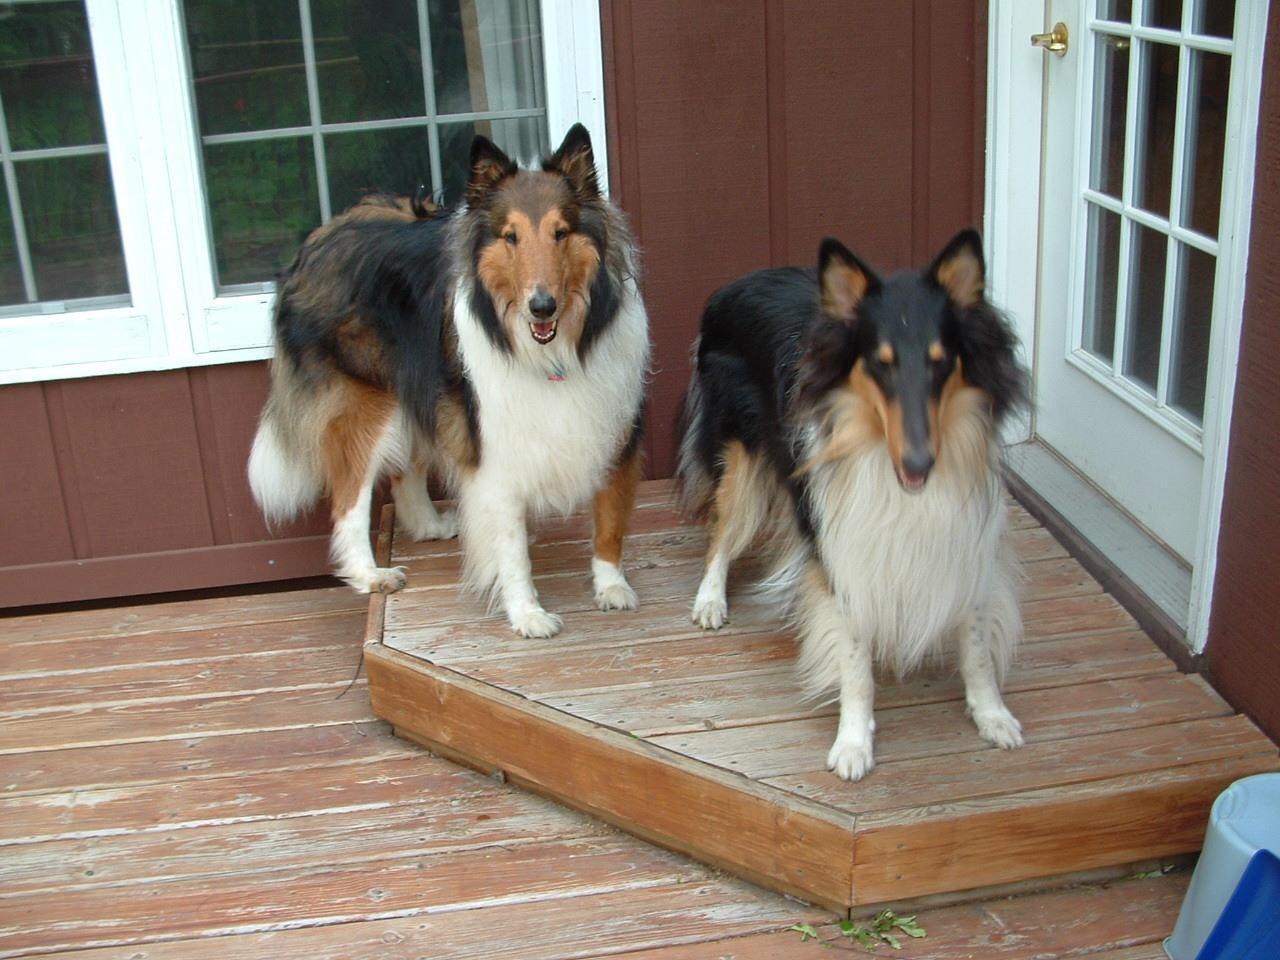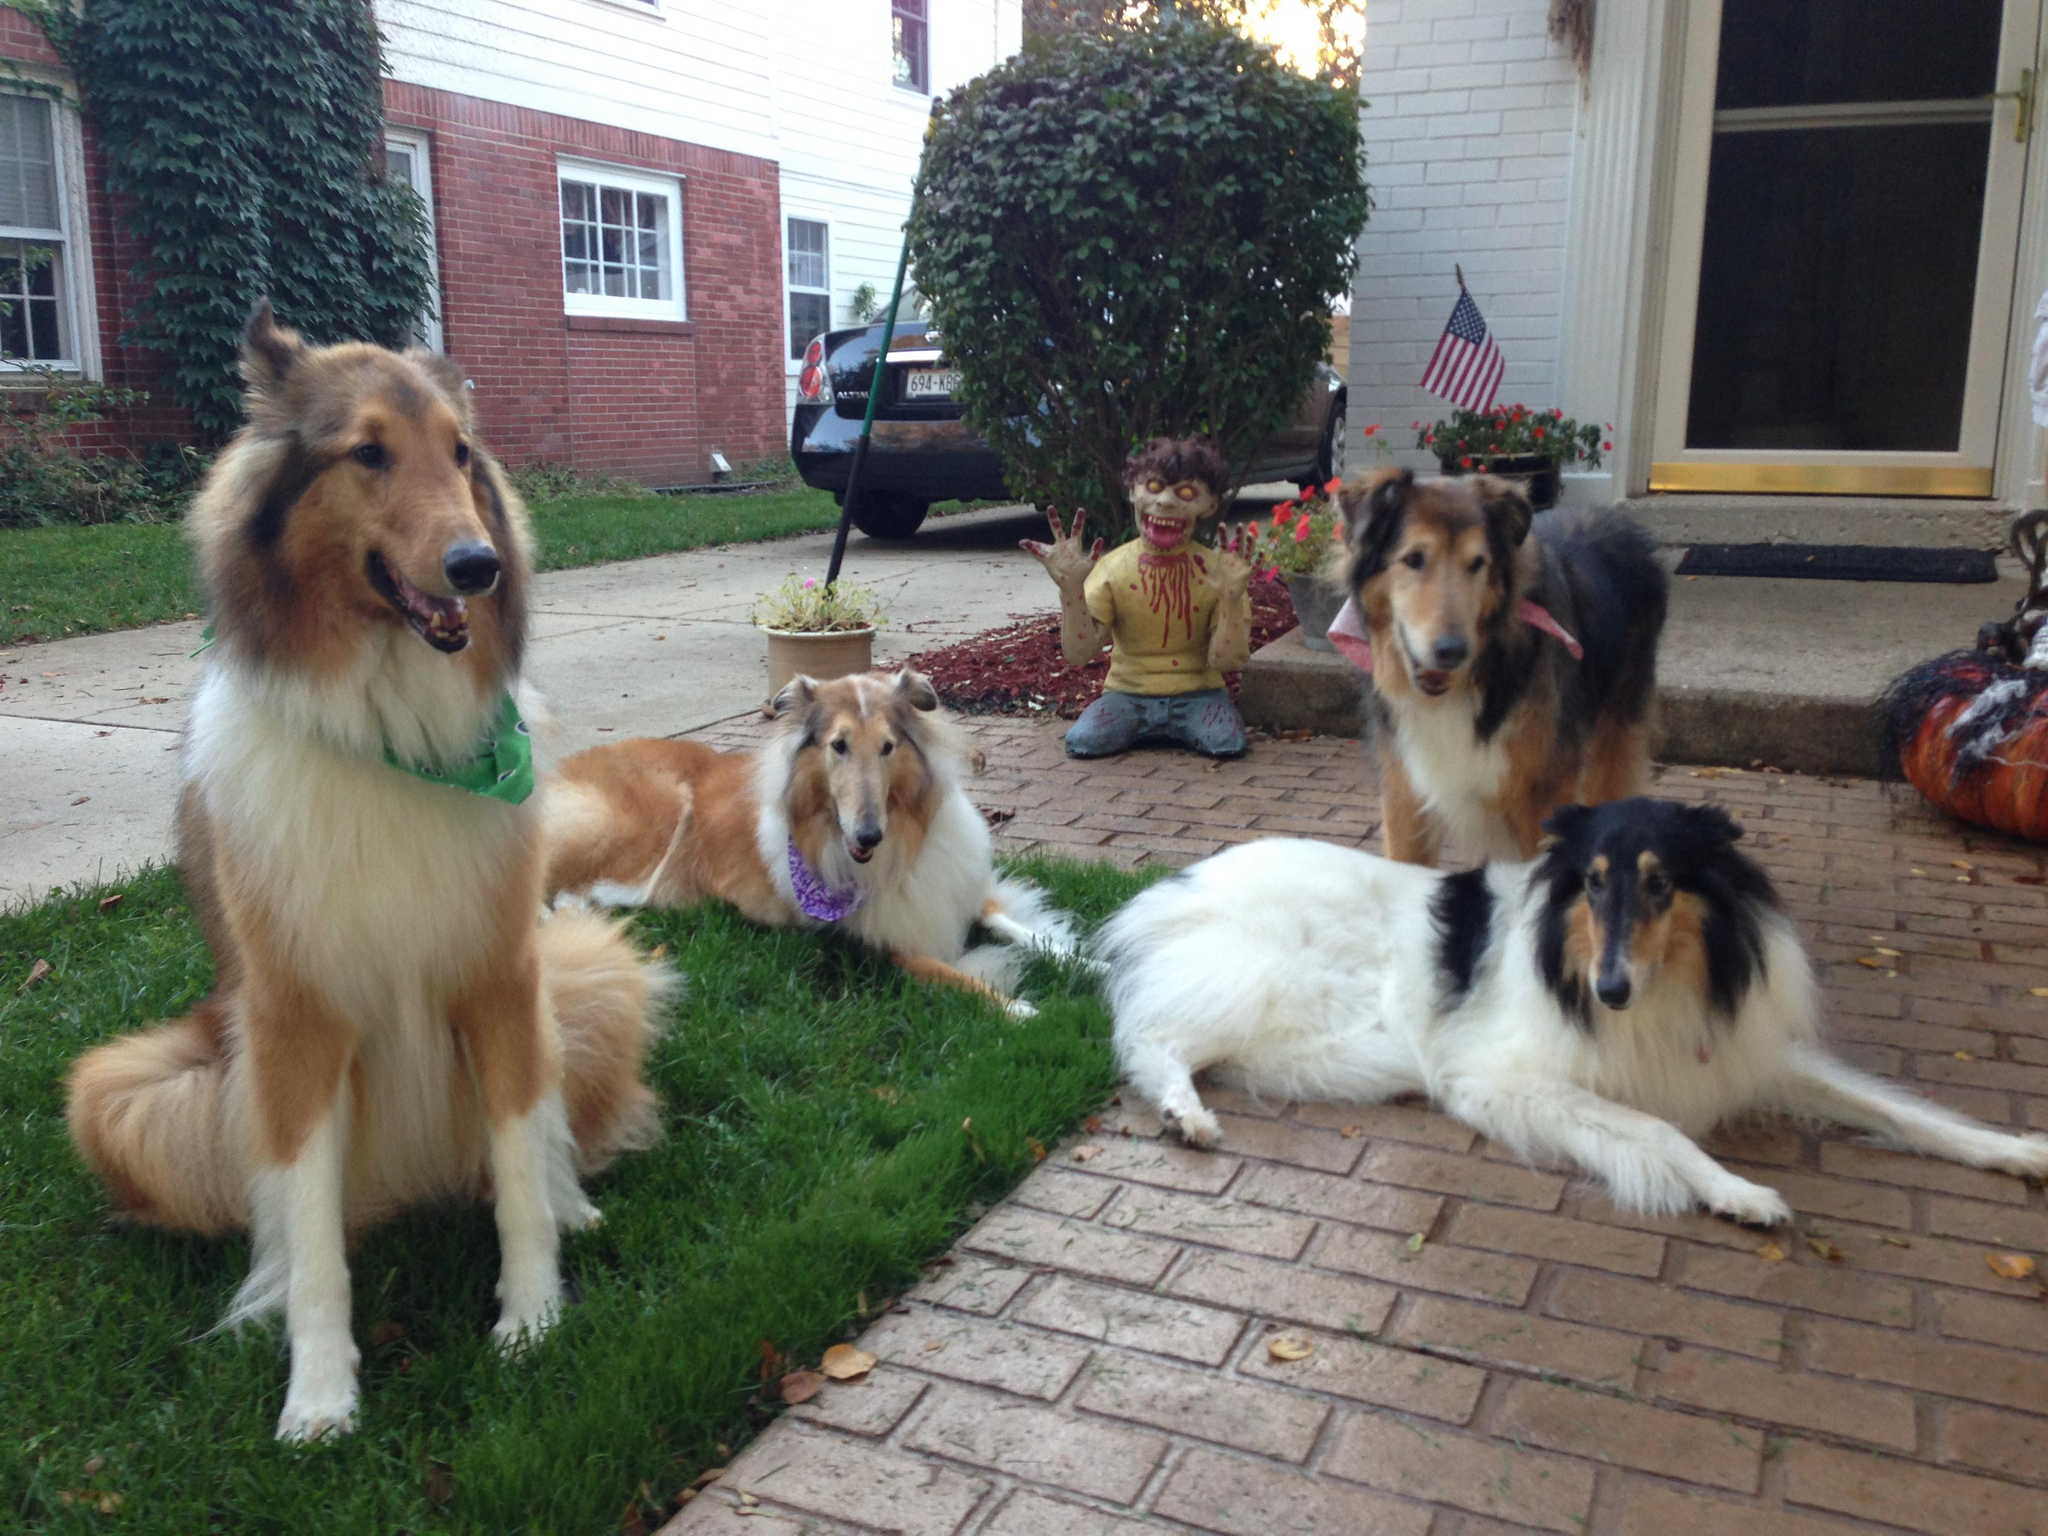The first image is the image on the left, the second image is the image on the right. For the images displayed, is the sentence "The right image contains exactly two dogs." factually correct? Answer yes or no. No. The first image is the image on the left, the second image is the image on the right. Analyze the images presented: Is the assertion "No single image contains more than two dogs, all images show dogs on a grass background, and at least one image includes a familiar collie breed." valid? Answer yes or no. No. 